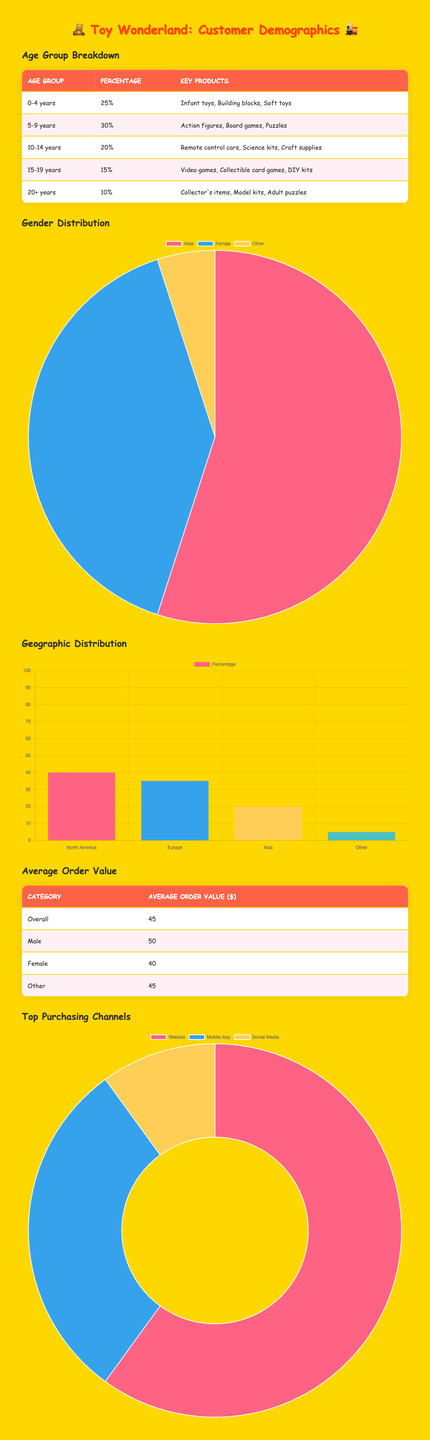What is the percentage of customers aged 0-4 years? From the table, the percentage for the age group 0-4 years is directly listed as 25%.
Answer: 25% Which age group has the highest percentage of toy purchases? The age group with the highest percentage is 5-9 years, which is 30%. This is clearly stated in the table, allowing for a straightforward comparison.
Answer: 5-9 years Is the average order value higher for males compared to females? According to the average order value section, males have an average order value of 50, while females have an average of 40. Since 50 is greater than 40, the answer is yes.
Answer: Yes What percentage of sales comes from mobile app purchases? The table shows that mobile app purchases account for 30% of total sales, which can be directly retrieved from the top purchasing channels section.
Answer: 30% If we sum the percentages of age groups for 10-14 years, 15-19 years, and 20+ years, what total do we get? The percentages for these age groups are 20% (10-14 years), 15% (15-19 years), and 10% (20+ years). Summing these gives 20 + 15 + 10 = 45%.
Answer: 45% What percentage of customers identify as "Other" in gender? The table specifies that 5% of customers identify as "Other." This value is explicitly stated in the gender distribution section.
Answer: 5% How does the average order value for the "Other" gender category compare to the overall average order value? The average order value for "Other" is 45, while the overall average order value is also 45. Since both values are equal, they are the same, confirming no difference.
Answer: They are the same Which geographic region has a higher percentage of toy purchases: Asia or Europe? Looking at the geographic distribution, Europe has 35% while Asia has 20%. Since 35% is greater than 20%, Europe has a higher percentage of toy purchases.
Answer: Europe What is the total percentage accounted for by customers aged 0-9 years? The percentages for the age groups 0-4 years (25%) and 5-9 years (30%) need to be added together. 25 + 30 = 55%. Therefore, the total percentage for these age groups is 55%.
Answer: 55% 